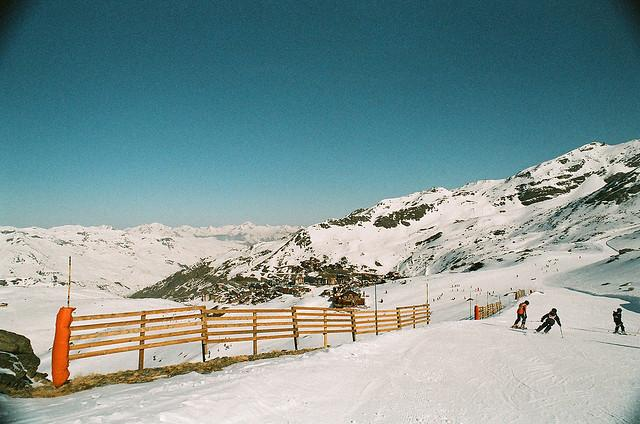What use is the fencing shown here? Please explain your reasoning. boundary guideline. People need to stay on one side of the fence to go down the hill. 